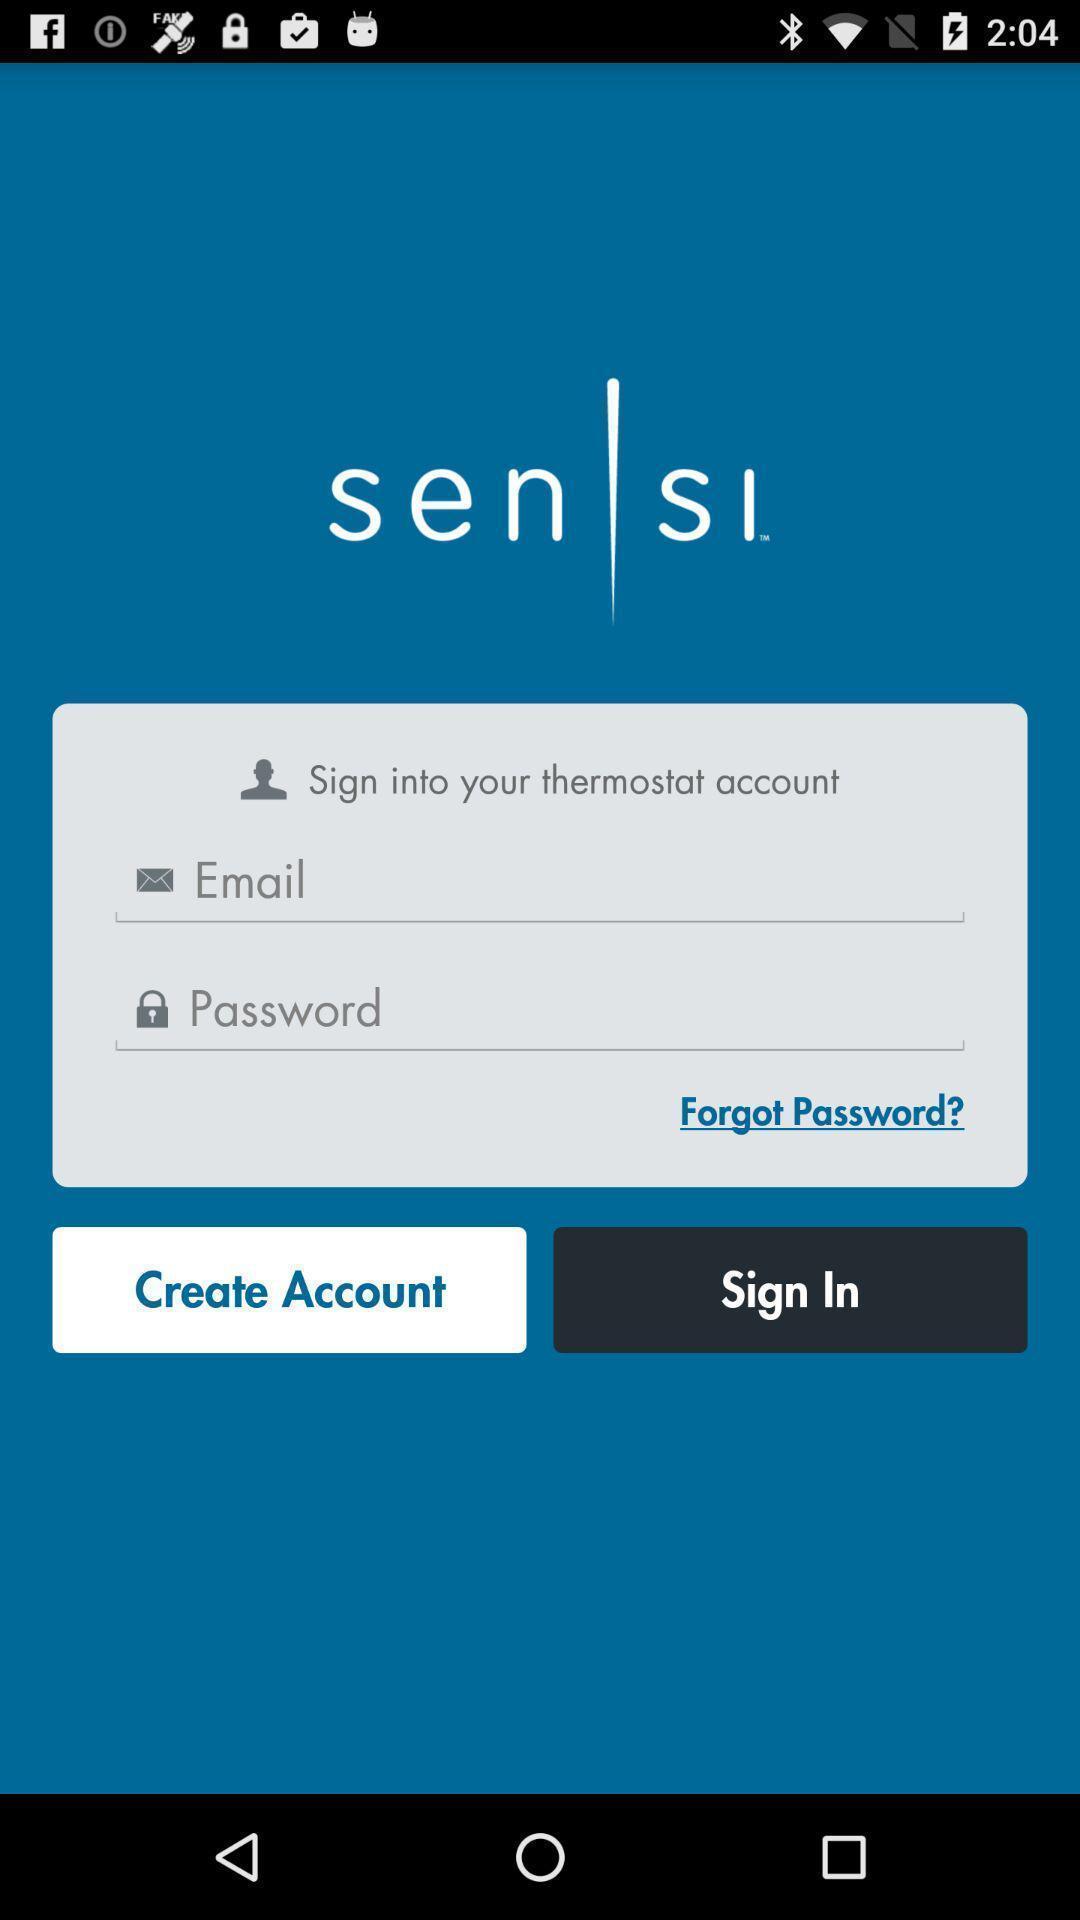Explain the elements present in this screenshot. Sign in page of application to get access. 